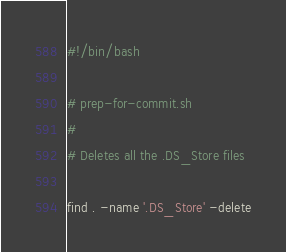<code> <loc_0><loc_0><loc_500><loc_500><_Bash_>#!/bin/bash

# prep-for-commit.sh
#
# Deletes all the .DS_Store files

find . -name '.DS_Store' -delete</code> 